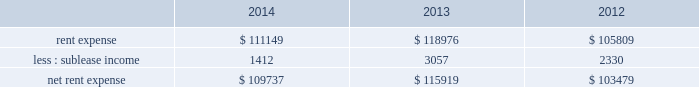Adobe systems incorporated notes to consolidated financial statements ( continued ) note 15 .
Commitments and contingencies lease commitments we lease certain of our facilities and some of our equipment under non-cancellable operating lease arrangements that expire at various dates through 2028 .
We also have one land lease that expires in 2091 .
Rent expense includes base contractual rent and variable costs such as building expenses , utilities , taxes , insurance and equipment rental .
Rent expense and sublease income for these leases for fiscal 2014 , 2013 and 2012 were as follows ( in thousands ) : .
We occupy three office buildings in san jose , california where our corporate headquarters are located .
We reference these office buildings as the almaden tower and the east and west towers .
In august 2014 , we exercised our option to purchase the east and west towers for a total purchase price of $ 143.2 million .
Upon purchase , our investment in the lease receivable of $ 126.8 million was credited against the total purchase price and we were no longer required to maintain a standby letter of credit as stipulated in the east and west towers lease agreement .
We capitalized the east and west towers as property and equipment on our consolidated balance sheets at $ 144.1 million , the lesser of cost or fair value , which represented the total purchase price plus other direct costs associated with the purchase .
See note 6 for discussion of our east and west towers purchase .
The lease agreement for the almaden tower is effective through march 2017 .
We are the investors in the lease receivable related to the almaden tower lease in the amount of $ 80.4 million , which is recorded as investment in lease receivable on our consolidated balance sheets .
As of november 28 , 2014 , the carrying value of the lease receivable related to the almaden tower approximated fair value .
Under the agreement for the almaden tower , we have the option to purchase the building at any time during the lease term for $ 103.6 million .
If we purchase the building , the investment in the lease receivable may be credited against the purchase price .
The residual value guarantee under the almaden tower obligation is $ 89.4 million .
The almaden tower lease is subject to standard covenants including certain financial ratios that are reported to the lessor quarterly .
As of november 28 , 2014 , we were in compliance with all of the covenants .
In the case of a default , the lessor may demand we purchase the building for an amount equal to the lease balance , or require that we remarket or relinquish the building .
If we choose to remarket or are required to do so upon relinquishing the building , we are bound to arrange the sale of the building to an unrelated party and will be required to pay the lessor any shortfall between the net remarketing proceeds and the lease balance , up to the residual value guarantee amount less our investment in lease receivable .
The almaden tower lease qualifies for operating lease accounting treatment and , as such , the building and the related obligation are not included in our consolidated balance sheets .
See note 16 for discussion of our capital lease obligation .
Unconditional purchase obligations our purchase obligations consist of agreements to purchase goods and services entered into in the ordinary course of business. .
What is the growth rate in the net rent expense in 2014? 
Computations: ((109737 - 115919) / 115919)
Answer: -0.05333. 